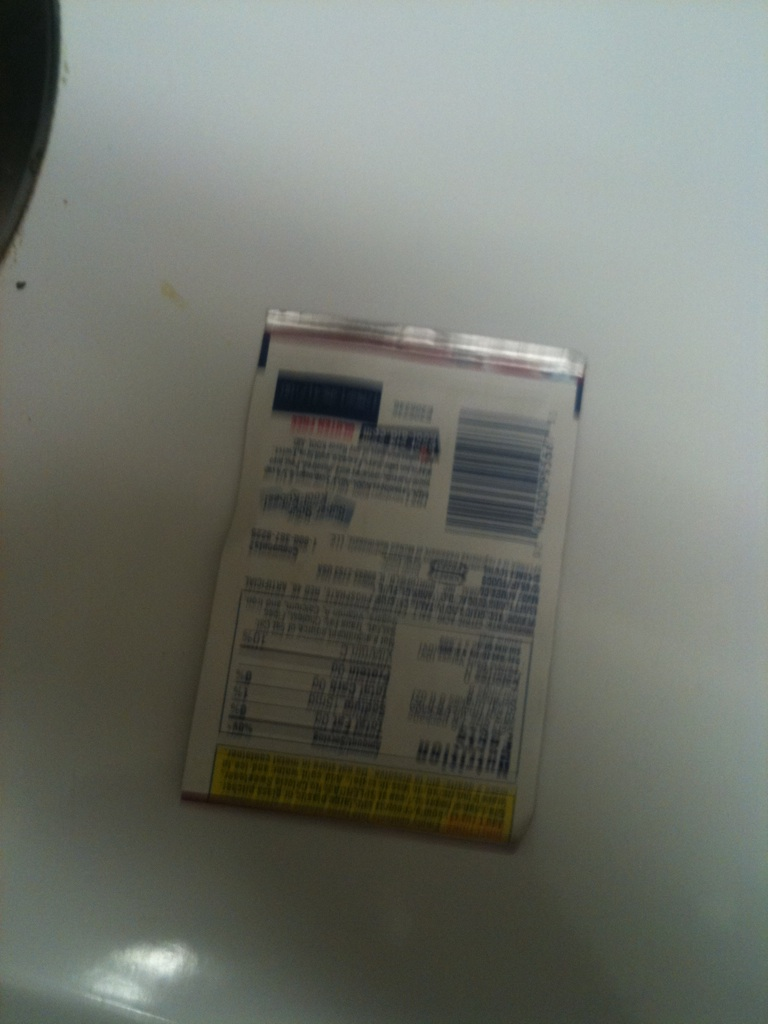What flavor is this? The image appears to be of the backside of a product package, and it's not possible to determine the flavor from this view alone. To identify the flavor, we would need to see the front of the package where such information is typically displayed. 